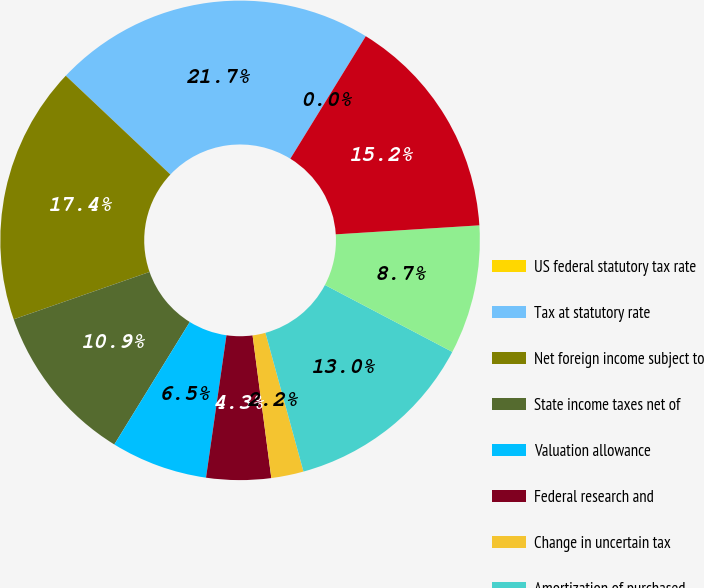Convert chart to OTSL. <chart><loc_0><loc_0><loc_500><loc_500><pie_chart><fcel>US federal statutory tax rate<fcel>Tax at statutory rate<fcel>Net foreign income subject to<fcel>State income taxes net of<fcel>Valuation allowance<fcel>Federal research and<fcel>Change in uncertain tax<fcel>Amortization of purchased<fcel>Other net<fcel>Total income tax provision<nl><fcel>0.0%<fcel>21.74%<fcel>17.39%<fcel>10.87%<fcel>6.52%<fcel>4.35%<fcel>2.18%<fcel>13.04%<fcel>8.7%<fcel>15.22%<nl></chart> 